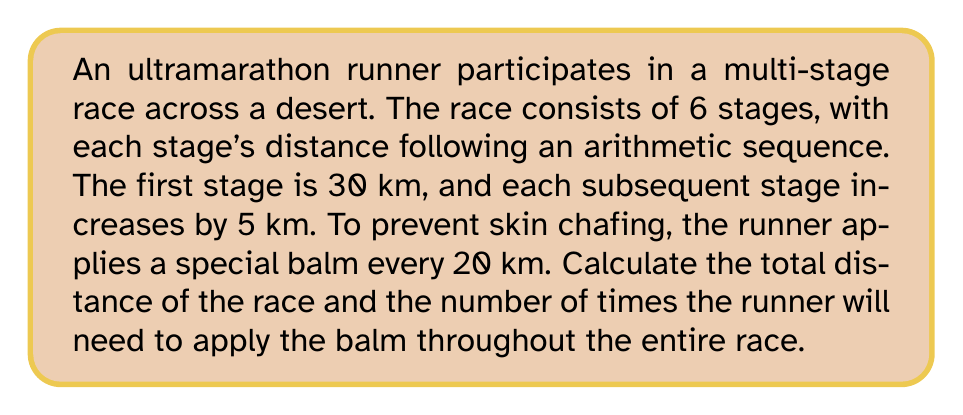Show me your answer to this math problem. 1. First, let's calculate the total distance of the race:
   - We have an arithmetic sequence with 6 terms
   - First term $a_1 = 30$ km
   - Common difference $d = 5$ km

   We can use the arithmetic sequence sum formula:
   $$S_n = \frac{n}{2}(a_1 + a_n)$$
   where $n$ is the number of terms, $a_1$ is the first term, and $a_n$ is the last term.

2. Calculate the last term $a_6$:
   $$a_n = a_1 + (n-1)d$$
   $$a_6 = 30 + (6-1)5 = 30 + 25 = 55$$ km

3. Now we can calculate the total distance:
   $$S_6 = \frac{6}{2}(30 + 55) = 3(85) = 255$$ km

4. To find how many times the runner needs to apply the balm:
   - The balm is applied every 20 km
   - Divide the total distance by 20 and round up to the nearest integer
   $$\text{Number of applications} = \left\lceil\frac{255}{20}\right\rceil = \left\lceil12.75\right\rceil = 13$$
Answer: 255 km; 13 times 